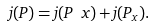<formula> <loc_0><loc_0><loc_500><loc_500>j ( P ) = j ( P \ x ) + j ( P _ { x } ) .</formula> 